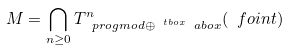<formula> <loc_0><loc_0><loc_500><loc_500>M = \bigcap _ { n \geq 0 } T _ { \ p r o g m o d \oplus ^ { \ t b o x } \ a b o x } ^ { n } ( \ f o i n t )</formula> 